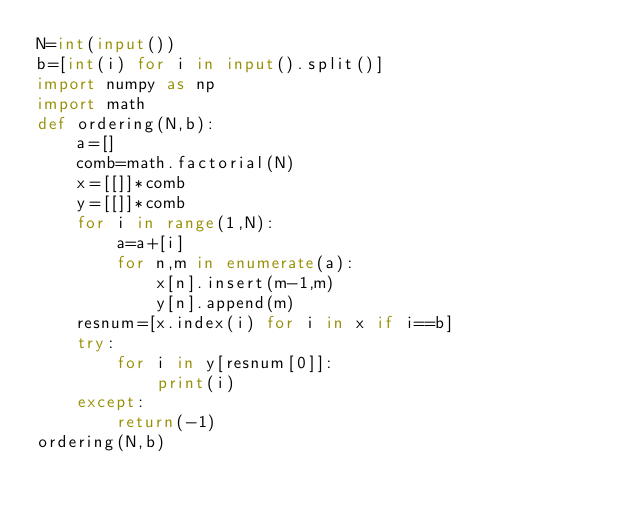<code> <loc_0><loc_0><loc_500><loc_500><_Python_>N=int(input())
b=[int(i) for i in input().split()]
import numpy as np
import math
def ordering(N,b):
    a=[]
    comb=math.factorial(N)
    x=[[]]*comb
    y=[[]]*comb
    for i in range(1,N):
        a=a+[i]
        for n,m in enumerate(a):
            x[n].insert(m-1,m)
            y[n].append(m)
    resnum=[x.index(i) for i in x if i==b]
    try:
        for i in y[resnum[0]]:
            print(i)
    except:
        return(-1)
ordering(N,b)</code> 